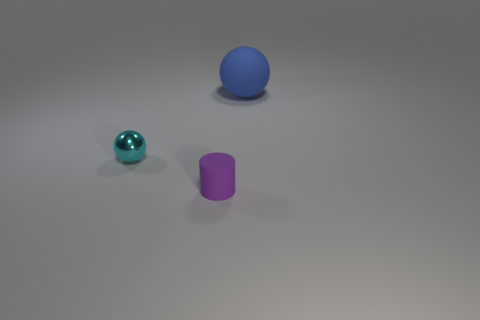Add 3 blue matte spheres. How many objects exist? 6 Subtract all balls. How many objects are left? 1 Add 2 large matte balls. How many large matte balls are left? 3 Add 3 cyan balls. How many cyan balls exist? 4 Subtract 0 yellow blocks. How many objects are left? 3 Subtract all tiny blue matte blocks. Subtract all small objects. How many objects are left? 1 